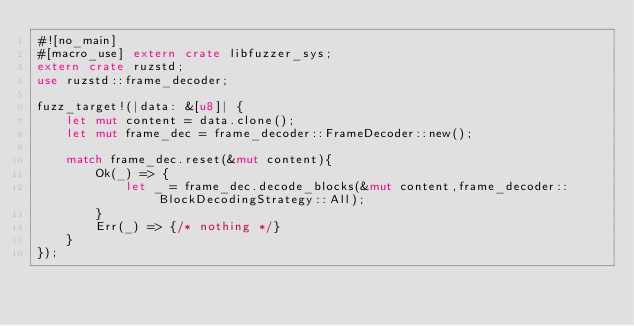<code> <loc_0><loc_0><loc_500><loc_500><_Rust_>#![no_main]
#[macro_use] extern crate libfuzzer_sys;
extern crate ruzstd;
use ruzstd::frame_decoder;

fuzz_target!(|data: &[u8]| {
    let mut content = data.clone();
    let mut frame_dec = frame_decoder::FrameDecoder::new();

    match frame_dec.reset(&mut content){
        Ok(_) => {
            let _ = frame_dec.decode_blocks(&mut content,frame_decoder::BlockDecodingStrategy::All);
        }
        Err(_) => {/* nothing */}
    }
});
</code> 